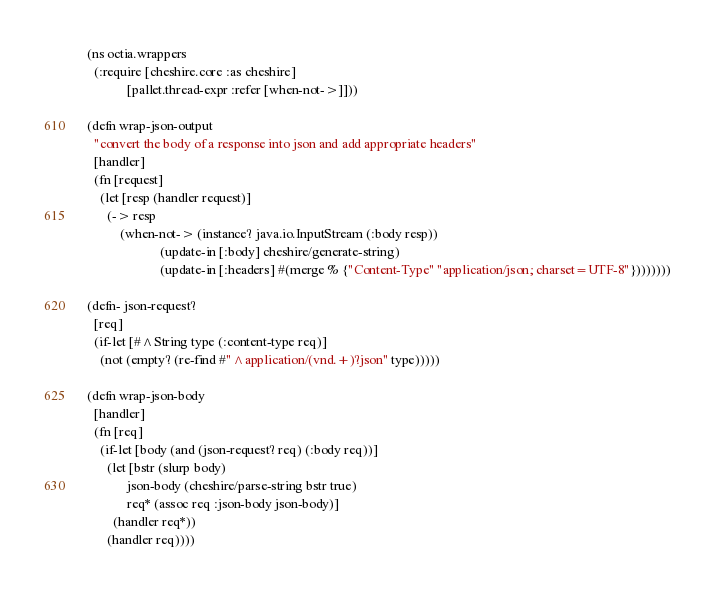Convert code to text. <code><loc_0><loc_0><loc_500><loc_500><_Clojure_>(ns octia.wrappers
  (:require [cheshire.core :as cheshire]
            [pallet.thread-expr :refer [when-not->]]))

(defn wrap-json-output
  "convert the body of a response into json and add appropriate headers"
  [handler]
  (fn [request]
    (let [resp (handler request)]
      (-> resp
          (when-not-> (instance? java.io.InputStream (:body resp))
                      (update-in [:body] cheshire/generate-string)
                      (update-in [:headers] #(merge % {"Content-Type" "application/json; charset=UTF-8"})))))))

(defn- json-request?
  [req]
  (if-let [#^String type (:content-type req)]
    (not (empty? (re-find #"^application/(vnd.+)?json" type)))))

(defn wrap-json-body
  [handler]
  (fn [req]
    (if-let [body (and (json-request? req) (:body req))]
      (let [bstr (slurp body)
            json-body (cheshire/parse-string bstr true)
            req* (assoc req :json-body json-body)]
        (handler req*))
      (handler req))))
</code> 